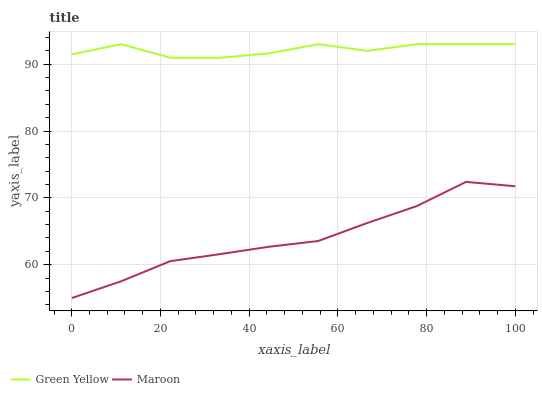Does Maroon have the maximum area under the curve?
Answer yes or no. No. Is Maroon the roughest?
Answer yes or no. No. Does Maroon have the highest value?
Answer yes or no. No. Is Maroon less than Green Yellow?
Answer yes or no. Yes. Is Green Yellow greater than Maroon?
Answer yes or no. Yes. Does Maroon intersect Green Yellow?
Answer yes or no. No. 